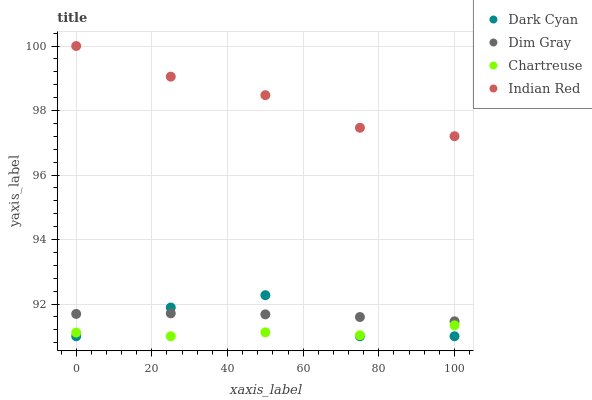Does Chartreuse have the minimum area under the curve?
Answer yes or no. Yes. Does Indian Red have the maximum area under the curve?
Answer yes or no. Yes. Does Dim Gray have the minimum area under the curve?
Answer yes or no. No. Does Dim Gray have the maximum area under the curve?
Answer yes or no. No. Is Dim Gray the smoothest?
Answer yes or no. Yes. Is Dark Cyan the roughest?
Answer yes or no. Yes. Is Chartreuse the smoothest?
Answer yes or no. No. Is Chartreuse the roughest?
Answer yes or no. No. Does Dark Cyan have the lowest value?
Answer yes or no. Yes. Does Dim Gray have the lowest value?
Answer yes or no. No. Does Indian Red have the highest value?
Answer yes or no. Yes. Does Dim Gray have the highest value?
Answer yes or no. No. Is Chartreuse less than Indian Red?
Answer yes or no. Yes. Is Indian Red greater than Chartreuse?
Answer yes or no. Yes. Does Chartreuse intersect Dark Cyan?
Answer yes or no. Yes. Is Chartreuse less than Dark Cyan?
Answer yes or no. No. Is Chartreuse greater than Dark Cyan?
Answer yes or no. No. Does Chartreuse intersect Indian Red?
Answer yes or no. No. 